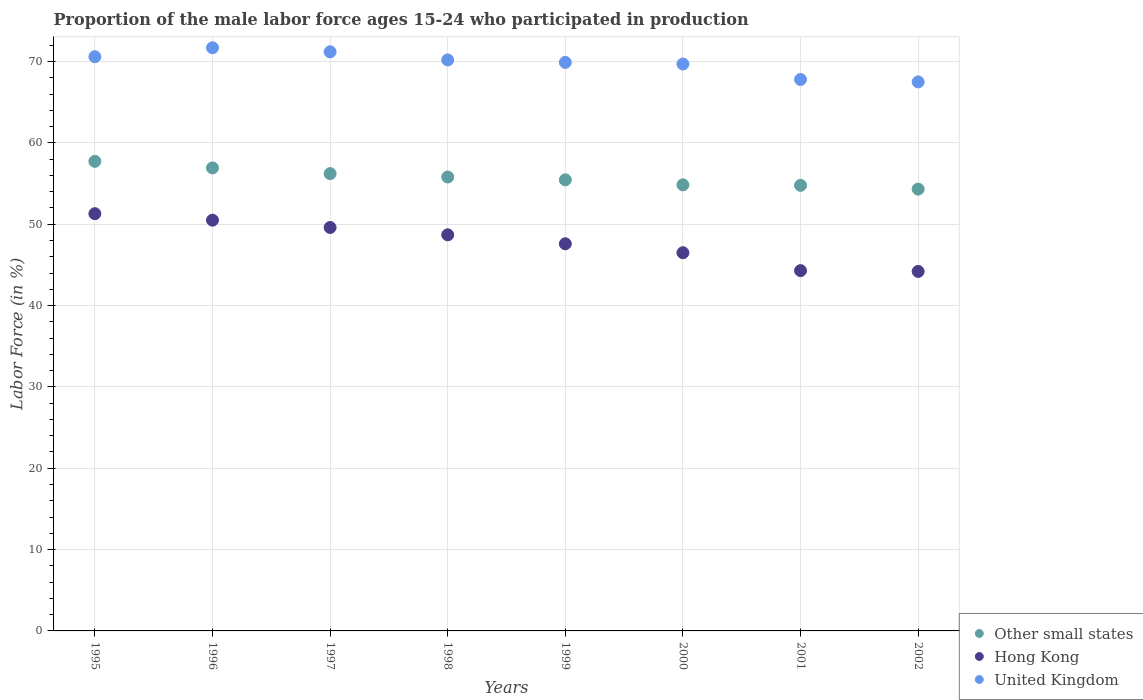Is the number of dotlines equal to the number of legend labels?
Your answer should be compact. Yes. What is the proportion of the male labor force who participated in production in Hong Kong in 1996?
Give a very brief answer. 50.5. Across all years, what is the maximum proportion of the male labor force who participated in production in Other small states?
Offer a terse response. 57.74. Across all years, what is the minimum proportion of the male labor force who participated in production in Hong Kong?
Ensure brevity in your answer.  44.2. In which year was the proportion of the male labor force who participated in production in United Kingdom maximum?
Ensure brevity in your answer.  1996. What is the total proportion of the male labor force who participated in production in Hong Kong in the graph?
Ensure brevity in your answer.  382.7. What is the difference between the proportion of the male labor force who participated in production in Hong Kong in 1997 and the proportion of the male labor force who participated in production in United Kingdom in 1995?
Your answer should be compact. -21. What is the average proportion of the male labor force who participated in production in Hong Kong per year?
Your answer should be very brief. 47.84. In the year 1995, what is the difference between the proportion of the male labor force who participated in production in Hong Kong and proportion of the male labor force who participated in production in United Kingdom?
Offer a very short reply. -19.3. What is the ratio of the proportion of the male labor force who participated in production in Hong Kong in 1997 to that in 1998?
Give a very brief answer. 1.02. Is the difference between the proportion of the male labor force who participated in production in Hong Kong in 1996 and 2000 greater than the difference between the proportion of the male labor force who participated in production in United Kingdom in 1996 and 2000?
Offer a very short reply. Yes. What is the difference between the highest and the second highest proportion of the male labor force who participated in production in Hong Kong?
Your response must be concise. 0.8. What is the difference between the highest and the lowest proportion of the male labor force who participated in production in United Kingdom?
Ensure brevity in your answer.  4.2. In how many years, is the proportion of the male labor force who participated in production in Hong Kong greater than the average proportion of the male labor force who participated in production in Hong Kong taken over all years?
Keep it short and to the point. 4. Is it the case that in every year, the sum of the proportion of the male labor force who participated in production in Other small states and proportion of the male labor force who participated in production in United Kingdom  is greater than the proportion of the male labor force who participated in production in Hong Kong?
Your response must be concise. Yes. Does the proportion of the male labor force who participated in production in United Kingdom monotonically increase over the years?
Your response must be concise. No. How many dotlines are there?
Offer a terse response. 3. How many years are there in the graph?
Your answer should be very brief. 8. What is the difference between two consecutive major ticks on the Y-axis?
Provide a succinct answer. 10. Are the values on the major ticks of Y-axis written in scientific E-notation?
Offer a terse response. No. Does the graph contain any zero values?
Provide a short and direct response. No. Does the graph contain grids?
Your answer should be compact. Yes. Where does the legend appear in the graph?
Give a very brief answer. Bottom right. How many legend labels are there?
Your response must be concise. 3. How are the legend labels stacked?
Your answer should be very brief. Vertical. What is the title of the graph?
Provide a short and direct response. Proportion of the male labor force ages 15-24 who participated in production. Does "Iraq" appear as one of the legend labels in the graph?
Your answer should be very brief. No. What is the Labor Force (in %) of Other small states in 1995?
Provide a succinct answer. 57.74. What is the Labor Force (in %) of Hong Kong in 1995?
Your answer should be compact. 51.3. What is the Labor Force (in %) in United Kingdom in 1995?
Provide a short and direct response. 70.6. What is the Labor Force (in %) in Other small states in 1996?
Your answer should be compact. 56.93. What is the Labor Force (in %) in Hong Kong in 1996?
Make the answer very short. 50.5. What is the Labor Force (in %) of United Kingdom in 1996?
Provide a succinct answer. 71.7. What is the Labor Force (in %) in Other small states in 1997?
Offer a terse response. 56.22. What is the Labor Force (in %) of Hong Kong in 1997?
Make the answer very short. 49.6. What is the Labor Force (in %) of United Kingdom in 1997?
Keep it short and to the point. 71.2. What is the Labor Force (in %) in Other small states in 1998?
Your response must be concise. 55.81. What is the Labor Force (in %) in Hong Kong in 1998?
Offer a terse response. 48.7. What is the Labor Force (in %) in United Kingdom in 1998?
Offer a terse response. 70.2. What is the Labor Force (in %) of Other small states in 1999?
Offer a terse response. 55.46. What is the Labor Force (in %) of Hong Kong in 1999?
Give a very brief answer. 47.6. What is the Labor Force (in %) in United Kingdom in 1999?
Your answer should be very brief. 69.9. What is the Labor Force (in %) of Other small states in 2000?
Make the answer very short. 54.84. What is the Labor Force (in %) of Hong Kong in 2000?
Ensure brevity in your answer.  46.5. What is the Labor Force (in %) in United Kingdom in 2000?
Offer a terse response. 69.7. What is the Labor Force (in %) of Other small states in 2001?
Your response must be concise. 54.78. What is the Labor Force (in %) in Hong Kong in 2001?
Offer a terse response. 44.3. What is the Labor Force (in %) of United Kingdom in 2001?
Provide a succinct answer. 67.8. What is the Labor Force (in %) in Other small states in 2002?
Your answer should be very brief. 54.32. What is the Labor Force (in %) of Hong Kong in 2002?
Make the answer very short. 44.2. What is the Labor Force (in %) of United Kingdom in 2002?
Ensure brevity in your answer.  67.5. Across all years, what is the maximum Labor Force (in %) in Other small states?
Offer a very short reply. 57.74. Across all years, what is the maximum Labor Force (in %) in Hong Kong?
Provide a short and direct response. 51.3. Across all years, what is the maximum Labor Force (in %) of United Kingdom?
Offer a very short reply. 71.7. Across all years, what is the minimum Labor Force (in %) of Other small states?
Offer a very short reply. 54.32. Across all years, what is the minimum Labor Force (in %) of Hong Kong?
Your response must be concise. 44.2. Across all years, what is the minimum Labor Force (in %) of United Kingdom?
Keep it short and to the point. 67.5. What is the total Labor Force (in %) in Other small states in the graph?
Make the answer very short. 446.1. What is the total Labor Force (in %) in Hong Kong in the graph?
Offer a very short reply. 382.7. What is the total Labor Force (in %) in United Kingdom in the graph?
Your answer should be compact. 558.6. What is the difference between the Labor Force (in %) in Other small states in 1995 and that in 1996?
Your answer should be compact. 0.81. What is the difference between the Labor Force (in %) in United Kingdom in 1995 and that in 1996?
Ensure brevity in your answer.  -1.1. What is the difference between the Labor Force (in %) in Other small states in 1995 and that in 1997?
Ensure brevity in your answer.  1.51. What is the difference between the Labor Force (in %) of Hong Kong in 1995 and that in 1997?
Your answer should be compact. 1.7. What is the difference between the Labor Force (in %) of Other small states in 1995 and that in 1998?
Your response must be concise. 1.93. What is the difference between the Labor Force (in %) in Hong Kong in 1995 and that in 1998?
Your answer should be very brief. 2.6. What is the difference between the Labor Force (in %) of United Kingdom in 1995 and that in 1998?
Keep it short and to the point. 0.4. What is the difference between the Labor Force (in %) of Other small states in 1995 and that in 1999?
Provide a short and direct response. 2.27. What is the difference between the Labor Force (in %) of United Kingdom in 1995 and that in 1999?
Offer a very short reply. 0.7. What is the difference between the Labor Force (in %) in Other small states in 1995 and that in 2000?
Your answer should be very brief. 2.89. What is the difference between the Labor Force (in %) of Hong Kong in 1995 and that in 2000?
Your response must be concise. 4.8. What is the difference between the Labor Force (in %) in United Kingdom in 1995 and that in 2000?
Provide a succinct answer. 0.9. What is the difference between the Labor Force (in %) of Other small states in 1995 and that in 2001?
Your response must be concise. 2.95. What is the difference between the Labor Force (in %) of Other small states in 1995 and that in 2002?
Provide a short and direct response. 3.42. What is the difference between the Labor Force (in %) of Hong Kong in 1995 and that in 2002?
Make the answer very short. 7.1. What is the difference between the Labor Force (in %) in United Kingdom in 1995 and that in 2002?
Provide a short and direct response. 3.1. What is the difference between the Labor Force (in %) of Other small states in 1996 and that in 1997?
Provide a short and direct response. 0.7. What is the difference between the Labor Force (in %) of Other small states in 1996 and that in 1998?
Give a very brief answer. 1.12. What is the difference between the Labor Force (in %) of Hong Kong in 1996 and that in 1998?
Keep it short and to the point. 1.8. What is the difference between the Labor Force (in %) in Other small states in 1996 and that in 1999?
Your answer should be compact. 1.46. What is the difference between the Labor Force (in %) in Hong Kong in 1996 and that in 1999?
Offer a very short reply. 2.9. What is the difference between the Labor Force (in %) in United Kingdom in 1996 and that in 1999?
Offer a terse response. 1.8. What is the difference between the Labor Force (in %) of Other small states in 1996 and that in 2000?
Make the answer very short. 2.08. What is the difference between the Labor Force (in %) in Hong Kong in 1996 and that in 2000?
Offer a very short reply. 4. What is the difference between the Labor Force (in %) in United Kingdom in 1996 and that in 2000?
Your answer should be compact. 2. What is the difference between the Labor Force (in %) of Other small states in 1996 and that in 2001?
Give a very brief answer. 2.15. What is the difference between the Labor Force (in %) in Other small states in 1996 and that in 2002?
Provide a succinct answer. 2.61. What is the difference between the Labor Force (in %) of Other small states in 1997 and that in 1998?
Make the answer very short. 0.41. What is the difference between the Labor Force (in %) in Hong Kong in 1997 and that in 1998?
Your response must be concise. 0.9. What is the difference between the Labor Force (in %) of United Kingdom in 1997 and that in 1998?
Your response must be concise. 1. What is the difference between the Labor Force (in %) in Other small states in 1997 and that in 1999?
Your answer should be very brief. 0.76. What is the difference between the Labor Force (in %) of United Kingdom in 1997 and that in 1999?
Ensure brevity in your answer.  1.3. What is the difference between the Labor Force (in %) of Other small states in 1997 and that in 2000?
Your response must be concise. 1.38. What is the difference between the Labor Force (in %) of Hong Kong in 1997 and that in 2000?
Your response must be concise. 3.1. What is the difference between the Labor Force (in %) of United Kingdom in 1997 and that in 2000?
Your response must be concise. 1.5. What is the difference between the Labor Force (in %) in Other small states in 1997 and that in 2001?
Make the answer very short. 1.44. What is the difference between the Labor Force (in %) in United Kingdom in 1997 and that in 2001?
Provide a short and direct response. 3.4. What is the difference between the Labor Force (in %) in Other small states in 1997 and that in 2002?
Provide a succinct answer. 1.9. What is the difference between the Labor Force (in %) in Hong Kong in 1997 and that in 2002?
Your answer should be very brief. 5.4. What is the difference between the Labor Force (in %) of Other small states in 1998 and that in 1999?
Ensure brevity in your answer.  0.35. What is the difference between the Labor Force (in %) of Hong Kong in 1998 and that in 1999?
Your answer should be very brief. 1.1. What is the difference between the Labor Force (in %) of United Kingdom in 1998 and that in 1999?
Provide a short and direct response. 0.3. What is the difference between the Labor Force (in %) of Other small states in 1998 and that in 2000?
Provide a succinct answer. 0.97. What is the difference between the Labor Force (in %) in United Kingdom in 1998 and that in 2000?
Offer a terse response. 0.5. What is the difference between the Labor Force (in %) of Other small states in 1998 and that in 2001?
Offer a terse response. 1.03. What is the difference between the Labor Force (in %) in United Kingdom in 1998 and that in 2001?
Provide a succinct answer. 2.4. What is the difference between the Labor Force (in %) in Other small states in 1998 and that in 2002?
Your answer should be very brief. 1.49. What is the difference between the Labor Force (in %) of Other small states in 1999 and that in 2000?
Offer a terse response. 0.62. What is the difference between the Labor Force (in %) in United Kingdom in 1999 and that in 2000?
Ensure brevity in your answer.  0.2. What is the difference between the Labor Force (in %) in Other small states in 1999 and that in 2001?
Provide a short and direct response. 0.68. What is the difference between the Labor Force (in %) of United Kingdom in 1999 and that in 2001?
Provide a succinct answer. 2.1. What is the difference between the Labor Force (in %) in Hong Kong in 1999 and that in 2002?
Your answer should be compact. 3.4. What is the difference between the Labor Force (in %) in United Kingdom in 1999 and that in 2002?
Make the answer very short. 2.4. What is the difference between the Labor Force (in %) in Other small states in 2000 and that in 2001?
Make the answer very short. 0.06. What is the difference between the Labor Force (in %) of Hong Kong in 2000 and that in 2001?
Your answer should be compact. 2.2. What is the difference between the Labor Force (in %) in Other small states in 2000 and that in 2002?
Your answer should be very brief. 0.52. What is the difference between the Labor Force (in %) in Other small states in 2001 and that in 2002?
Offer a terse response. 0.46. What is the difference between the Labor Force (in %) of United Kingdom in 2001 and that in 2002?
Your answer should be very brief. 0.3. What is the difference between the Labor Force (in %) of Other small states in 1995 and the Labor Force (in %) of Hong Kong in 1996?
Make the answer very short. 7.24. What is the difference between the Labor Force (in %) in Other small states in 1995 and the Labor Force (in %) in United Kingdom in 1996?
Your answer should be compact. -13.96. What is the difference between the Labor Force (in %) in Hong Kong in 1995 and the Labor Force (in %) in United Kingdom in 1996?
Give a very brief answer. -20.4. What is the difference between the Labor Force (in %) of Other small states in 1995 and the Labor Force (in %) of Hong Kong in 1997?
Keep it short and to the point. 8.14. What is the difference between the Labor Force (in %) of Other small states in 1995 and the Labor Force (in %) of United Kingdom in 1997?
Offer a terse response. -13.46. What is the difference between the Labor Force (in %) in Hong Kong in 1995 and the Labor Force (in %) in United Kingdom in 1997?
Give a very brief answer. -19.9. What is the difference between the Labor Force (in %) of Other small states in 1995 and the Labor Force (in %) of Hong Kong in 1998?
Keep it short and to the point. 9.04. What is the difference between the Labor Force (in %) in Other small states in 1995 and the Labor Force (in %) in United Kingdom in 1998?
Your answer should be compact. -12.46. What is the difference between the Labor Force (in %) of Hong Kong in 1995 and the Labor Force (in %) of United Kingdom in 1998?
Ensure brevity in your answer.  -18.9. What is the difference between the Labor Force (in %) in Other small states in 1995 and the Labor Force (in %) in Hong Kong in 1999?
Your answer should be compact. 10.14. What is the difference between the Labor Force (in %) of Other small states in 1995 and the Labor Force (in %) of United Kingdom in 1999?
Make the answer very short. -12.16. What is the difference between the Labor Force (in %) of Hong Kong in 1995 and the Labor Force (in %) of United Kingdom in 1999?
Your answer should be very brief. -18.6. What is the difference between the Labor Force (in %) in Other small states in 1995 and the Labor Force (in %) in Hong Kong in 2000?
Provide a succinct answer. 11.24. What is the difference between the Labor Force (in %) of Other small states in 1995 and the Labor Force (in %) of United Kingdom in 2000?
Provide a short and direct response. -11.96. What is the difference between the Labor Force (in %) of Hong Kong in 1995 and the Labor Force (in %) of United Kingdom in 2000?
Give a very brief answer. -18.4. What is the difference between the Labor Force (in %) in Other small states in 1995 and the Labor Force (in %) in Hong Kong in 2001?
Keep it short and to the point. 13.44. What is the difference between the Labor Force (in %) of Other small states in 1995 and the Labor Force (in %) of United Kingdom in 2001?
Make the answer very short. -10.06. What is the difference between the Labor Force (in %) in Hong Kong in 1995 and the Labor Force (in %) in United Kingdom in 2001?
Make the answer very short. -16.5. What is the difference between the Labor Force (in %) in Other small states in 1995 and the Labor Force (in %) in Hong Kong in 2002?
Give a very brief answer. 13.54. What is the difference between the Labor Force (in %) in Other small states in 1995 and the Labor Force (in %) in United Kingdom in 2002?
Your answer should be compact. -9.76. What is the difference between the Labor Force (in %) in Hong Kong in 1995 and the Labor Force (in %) in United Kingdom in 2002?
Your response must be concise. -16.2. What is the difference between the Labor Force (in %) of Other small states in 1996 and the Labor Force (in %) of Hong Kong in 1997?
Your answer should be very brief. 7.33. What is the difference between the Labor Force (in %) of Other small states in 1996 and the Labor Force (in %) of United Kingdom in 1997?
Provide a succinct answer. -14.27. What is the difference between the Labor Force (in %) in Hong Kong in 1996 and the Labor Force (in %) in United Kingdom in 1997?
Ensure brevity in your answer.  -20.7. What is the difference between the Labor Force (in %) in Other small states in 1996 and the Labor Force (in %) in Hong Kong in 1998?
Give a very brief answer. 8.23. What is the difference between the Labor Force (in %) of Other small states in 1996 and the Labor Force (in %) of United Kingdom in 1998?
Give a very brief answer. -13.27. What is the difference between the Labor Force (in %) of Hong Kong in 1996 and the Labor Force (in %) of United Kingdom in 1998?
Your answer should be very brief. -19.7. What is the difference between the Labor Force (in %) of Other small states in 1996 and the Labor Force (in %) of Hong Kong in 1999?
Provide a succinct answer. 9.33. What is the difference between the Labor Force (in %) of Other small states in 1996 and the Labor Force (in %) of United Kingdom in 1999?
Ensure brevity in your answer.  -12.97. What is the difference between the Labor Force (in %) of Hong Kong in 1996 and the Labor Force (in %) of United Kingdom in 1999?
Your answer should be compact. -19.4. What is the difference between the Labor Force (in %) of Other small states in 1996 and the Labor Force (in %) of Hong Kong in 2000?
Offer a terse response. 10.43. What is the difference between the Labor Force (in %) in Other small states in 1996 and the Labor Force (in %) in United Kingdom in 2000?
Provide a short and direct response. -12.77. What is the difference between the Labor Force (in %) in Hong Kong in 1996 and the Labor Force (in %) in United Kingdom in 2000?
Keep it short and to the point. -19.2. What is the difference between the Labor Force (in %) of Other small states in 1996 and the Labor Force (in %) of Hong Kong in 2001?
Make the answer very short. 12.63. What is the difference between the Labor Force (in %) of Other small states in 1996 and the Labor Force (in %) of United Kingdom in 2001?
Keep it short and to the point. -10.87. What is the difference between the Labor Force (in %) in Hong Kong in 1996 and the Labor Force (in %) in United Kingdom in 2001?
Ensure brevity in your answer.  -17.3. What is the difference between the Labor Force (in %) in Other small states in 1996 and the Labor Force (in %) in Hong Kong in 2002?
Keep it short and to the point. 12.73. What is the difference between the Labor Force (in %) of Other small states in 1996 and the Labor Force (in %) of United Kingdom in 2002?
Provide a succinct answer. -10.57. What is the difference between the Labor Force (in %) of Other small states in 1997 and the Labor Force (in %) of Hong Kong in 1998?
Your answer should be compact. 7.52. What is the difference between the Labor Force (in %) of Other small states in 1997 and the Labor Force (in %) of United Kingdom in 1998?
Make the answer very short. -13.98. What is the difference between the Labor Force (in %) in Hong Kong in 1997 and the Labor Force (in %) in United Kingdom in 1998?
Offer a terse response. -20.6. What is the difference between the Labor Force (in %) of Other small states in 1997 and the Labor Force (in %) of Hong Kong in 1999?
Offer a terse response. 8.62. What is the difference between the Labor Force (in %) of Other small states in 1997 and the Labor Force (in %) of United Kingdom in 1999?
Your answer should be compact. -13.68. What is the difference between the Labor Force (in %) in Hong Kong in 1997 and the Labor Force (in %) in United Kingdom in 1999?
Your answer should be very brief. -20.3. What is the difference between the Labor Force (in %) in Other small states in 1997 and the Labor Force (in %) in Hong Kong in 2000?
Your answer should be compact. 9.72. What is the difference between the Labor Force (in %) in Other small states in 1997 and the Labor Force (in %) in United Kingdom in 2000?
Your answer should be very brief. -13.48. What is the difference between the Labor Force (in %) of Hong Kong in 1997 and the Labor Force (in %) of United Kingdom in 2000?
Your answer should be very brief. -20.1. What is the difference between the Labor Force (in %) of Other small states in 1997 and the Labor Force (in %) of Hong Kong in 2001?
Make the answer very short. 11.92. What is the difference between the Labor Force (in %) in Other small states in 1997 and the Labor Force (in %) in United Kingdom in 2001?
Your response must be concise. -11.58. What is the difference between the Labor Force (in %) in Hong Kong in 1997 and the Labor Force (in %) in United Kingdom in 2001?
Offer a terse response. -18.2. What is the difference between the Labor Force (in %) in Other small states in 1997 and the Labor Force (in %) in Hong Kong in 2002?
Keep it short and to the point. 12.02. What is the difference between the Labor Force (in %) of Other small states in 1997 and the Labor Force (in %) of United Kingdom in 2002?
Offer a very short reply. -11.28. What is the difference between the Labor Force (in %) in Hong Kong in 1997 and the Labor Force (in %) in United Kingdom in 2002?
Give a very brief answer. -17.9. What is the difference between the Labor Force (in %) of Other small states in 1998 and the Labor Force (in %) of Hong Kong in 1999?
Give a very brief answer. 8.21. What is the difference between the Labor Force (in %) in Other small states in 1998 and the Labor Force (in %) in United Kingdom in 1999?
Provide a short and direct response. -14.09. What is the difference between the Labor Force (in %) in Hong Kong in 1998 and the Labor Force (in %) in United Kingdom in 1999?
Provide a short and direct response. -21.2. What is the difference between the Labor Force (in %) of Other small states in 1998 and the Labor Force (in %) of Hong Kong in 2000?
Your answer should be compact. 9.31. What is the difference between the Labor Force (in %) in Other small states in 1998 and the Labor Force (in %) in United Kingdom in 2000?
Ensure brevity in your answer.  -13.89. What is the difference between the Labor Force (in %) in Hong Kong in 1998 and the Labor Force (in %) in United Kingdom in 2000?
Provide a succinct answer. -21. What is the difference between the Labor Force (in %) in Other small states in 1998 and the Labor Force (in %) in Hong Kong in 2001?
Ensure brevity in your answer.  11.51. What is the difference between the Labor Force (in %) of Other small states in 1998 and the Labor Force (in %) of United Kingdom in 2001?
Keep it short and to the point. -11.99. What is the difference between the Labor Force (in %) in Hong Kong in 1998 and the Labor Force (in %) in United Kingdom in 2001?
Keep it short and to the point. -19.1. What is the difference between the Labor Force (in %) of Other small states in 1998 and the Labor Force (in %) of Hong Kong in 2002?
Your answer should be very brief. 11.61. What is the difference between the Labor Force (in %) in Other small states in 1998 and the Labor Force (in %) in United Kingdom in 2002?
Offer a terse response. -11.69. What is the difference between the Labor Force (in %) in Hong Kong in 1998 and the Labor Force (in %) in United Kingdom in 2002?
Offer a terse response. -18.8. What is the difference between the Labor Force (in %) of Other small states in 1999 and the Labor Force (in %) of Hong Kong in 2000?
Offer a terse response. 8.96. What is the difference between the Labor Force (in %) in Other small states in 1999 and the Labor Force (in %) in United Kingdom in 2000?
Give a very brief answer. -14.24. What is the difference between the Labor Force (in %) of Hong Kong in 1999 and the Labor Force (in %) of United Kingdom in 2000?
Give a very brief answer. -22.1. What is the difference between the Labor Force (in %) of Other small states in 1999 and the Labor Force (in %) of Hong Kong in 2001?
Keep it short and to the point. 11.16. What is the difference between the Labor Force (in %) in Other small states in 1999 and the Labor Force (in %) in United Kingdom in 2001?
Make the answer very short. -12.34. What is the difference between the Labor Force (in %) of Hong Kong in 1999 and the Labor Force (in %) of United Kingdom in 2001?
Give a very brief answer. -20.2. What is the difference between the Labor Force (in %) in Other small states in 1999 and the Labor Force (in %) in Hong Kong in 2002?
Your answer should be very brief. 11.26. What is the difference between the Labor Force (in %) in Other small states in 1999 and the Labor Force (in %) in United Kingdom in 2002?
Your answer should be very brief. -12.04. What is the difference between the Labor Force (in %) of Hong Kong in 1999 and the Labor Force (in %) of United Kingdom in 2002?
Provide a succinct answer. -19.9. What is the difference between the Labor Force (in %) of Other small states in 2000 and the Labor Force (in %) of Hong Kong in 2001?
Your answer should be very brief. 10.54. What is the difference between the Labor Force (in %) in Other small states in 2000 and the Labor Force (in %) in United Kingdom in 2001?
Your response must be concise. -12.96. What is the difference between the Labor Force (in %) of Hong Kong in 2000 and the Labor Force (in %) of United Kingdom in 2001?
Offer a very short reply. -21.3. What is the difference between the Labor Force (in %) in Other small states in 2000 and the Labor Force (in %) in Hong Kong in 2002?
Make the answer very short. 10.64. What is the difference between the Labor Force (in %) in Other small states in 2000 and the Labor Force (in %) in United Kingdom in 2002?
Provide a succinct answer. -12.66. What is the difference between the Labor Force (in %) of Hong Kong in 2000 and the Labor Force (in %) of United Kingdom in 2002?
Provide a succinct answer. -21. What is the difference between the Labor Force (in %) of Other small states in 2001 and the Labor Force (in %) of Hong Kong in 2002?
Keep it short and to the point. 10.58. What is the difference between the Labor Force (in %) in Other small states in 2001 and the Labor Force (in %) in United Kingdom in 2002?
Offer a terse response. -12.72. What is the difference between the Labor Force (in %) of Hong Kong in 2001 and the Labor Force (in %) of United Kingdom in 2002?
Give a very brief answer. -23.2. What is the average Labor Force (in %) in Other small states per year?
Keep it short and to the point. 55.76. What is the average Labor Force (in %) of Hong Kong per year?
Offer a very short reply. 47.84. What is the average Labor Force (in %) in United Kingdom per year?
Make the answer very short. 69.83. In the year 1995, what is the difference between the Labor Force (in %) of Other small states and Labor Force (in %) of Hong Kong?
Offer a terse response. 6.44. In the year 1995, what is the difference between the Labor Force (in %) in Other small states and Labor Force (in %) in United Kingdom?
Offer a very short reply. -12.86. In the year 1995, what is the difference between the Labor Force (in %) of Hong Kong and Labor Force (in %) of United Kingdom?
Your answer should be compact. -19.3. In the year 1996, what is the difference between the Labor Force (in %) in Other small states and Labor Force (in %) in Hong Kong?
Your response must be concise. 6.43. In the year 1996, what is the difference between the Labor Force (in %) in Other small states and Labor Force (in %) in United Kingdom?
Ensure brevity in your answer.  -14.77. In the year 1996, what is the difference between the Labor Force (in %) of Hong Kong and Labor Force (in %) of United Kingdom?
Ensure brevity in your answer.  -21.2. In the year 1997, what is the difference between the Labor Force (in %) of Other small states and Labor Force (in %) of Hong Kong?
Ensure brevity in your answer.  6.62. In the year 1997, what is the difference between the Labor Force (in %) in Other small states and Labor Force (in %) in United Kingdom?
Provide a succinct answer. -14.98. In the year 1997, what is the difference between the Labor Force (in %) of Hong Kong and Labor Force (in %) of United Kingdom?
Offer a terse response. -21.6. In the year 1998, what is the difference between the Labor Force (in %) of Other small states and Labor Force (in %) of Hong Kong?
Provide a succinct answer. 7.11. In the year 1998, what is the difference between the Labor Force (in %) in Other small states and Labor Force (in %) in United Kingdom?
Offer a terse response. -14.39. In the year 1998, what is the difference between the Labor Force (in %) in Hong Kong and Labor Force (in %) in United Kingdom?
Offer a very short reply. -21.5. In the year 1999, what is the difference between the Labor Force (in %) of Other small states and Labor Force (in %) of Hong Kong?
Provide a short and direct response. 7.86. In the year 1999, what is the difference between the Labor Force (in %) of Other small states and Labor Force (in %) of United Kingdom?
Your answer should be compact. -14.44. In the year 1999, what is the difference between the Labor Force (in %) of Hong Kong and Labor Force (in %) of United Kingdom?
Your answer should be compact. -22.3. In the year 2000, what is the difference between the Labor Force (in %) in Other small states and Labor Force (in %) in Hong Kong?
Make the answer very short. 8.34. In the year 2000, what is the difference between the Labor Force (in %) in Other small states and Labor Force (in %) in United Kingdom?
Keep it short and to the point. -14.86. In the year 2000, what is the difference between the Labor Force (in %) in Hong Kong and Labor Force (in %) in United Kingdom?
Your response must be concise. -23.2. In the year 2001, what is the difference between the Labor Force (in %) of Other small states and Labor Force (in %) of Hong Kong?
Make the answer very short. 10.48. In the year 2001, what is the difference between the Labor Force (in %) of Other small states and Labor Force (in %) of United Kingdom?
Your response must be concise. -13.02. In the year 2001, what is the difference between the Labor Force (in %) of Hong Kong and Labor Force (in %) of United Kingdom?
Give a very brief answer. -23.5. In the year 2002, what is the difference between the Labor Force (in %) of Other small states and Labor Force (in %) of Hong Kong?
Give a very brief answer. 10.12. In the year 2002, what is the difference between the Labor Force (in %) in Other small states and Labor Force (in %) in United Kingdom?
Your answer should be compact. -13.18. In the year 2002, what is the difference between the Labor Force (in %) of Hong Kong and Labor Force (in %) of United Kingdom?
Make the answer very short. -23.3. What is the ratio of the Labor Force (in %) of Other small states in 1995 to that in 1996?
Your answer should be very brief. 1.01. What is the ratio of the Labor Force (in %) of Hong Kong in 1995 to that in 1996?
Give a very brief answer. 1.02. What is the ratio of the Labor Force (in %) in United Kingdom in 1995 to that in 1996?
Your response must be concise. 0.98. What is the ratio of the Labor Force (in %) of Other small states in 1995 to that in 1997?
Offer a very short reply. 1.03. What is the ratio of the Labor Force (in %) in Hong Kong in 1995 to that in 1997?
Make the answer very short. 1.03. What is the ratio of the Labor Force (in %) of United Kingdom in 1995 to that in 1997?
Your answer should be compact. 0.99. What is the ratio of the Labor Force (in %) in Other small states in 1995 to that in 1998?
Provide a short and direct response. 1.03. What is the ratio of the Labor Force (in %) in Hong Kong in 1995 to that in 1998?
Make the answer very short. 1.05. What is the ratio of the Labor Force (in %) of United Kingdom in 1995 to that in 1998?
Your answer should be compact. 1.01. What is the ratio of the Labor Force (in %) of Other small states in 1995 to that in 1999?
Provide a succinct answer. 1.04. What is the ratio of the Labor Force (in %) in Hong Kong in 1995 to that in 1999?
Your answer should be compact. 1.08. What is the ratio of the Labor Force (in %) in Other small states in 1995 to that in 2000?
Keep it short and to the point. 1.05. What is the ratio of the Labor Force (in %) in Hong Kong in 1995 to that in 2000?
Provide a short and direct response. 1.1. What is the ratio of the Labor Force (in %) of United Kingdom in 1995 to that in 2000?
Keep it short and to the point. 1.01. What is the ratio of the Labor Force (in %) of Other small states in 1995 to that in 2001?
Keep it short and to the point. 1.05. What is the ratio of the Labor Force (in %) in Hong Kong in 1995 to that in 2001?
Keep it short and to the point. 1.16. What is the ratio of the Labor Force (in %) of United Kingdom in 1995 to that in 2001?
Make the answer very short. 1.04. What is the ratio of the Labor Force (in %) in Other small states in 1995 to that in 2002?
Provide a succinct answer. 1.06. What is the ratio of the Labor Force (in %) of Hong Kong in 1995 to that in 2002?
Provide a succinct answer. 1.16. What is the ratio of the Labor Force (in %) of United Kingdom in 1995 to that in 2002?
Provide a succinct answer. 1.05. What is the ratio of the Labor Force (in %) in Other small states in 1996 to that in 1997?
Provide a short and direct response. 1.01. What is the ratio of the Labor Force (in %) of Hong Kong in 1996 to that in 1997?
Your response must be concise. 1.02. What is the ratio of the Labor Force (in %) of United Kingdom in 1996 to that in 1997?
Your answer should be very brief. 1.01. What is the ratio of the Labor Force (in %) of Other small states in 1996 to that in 1998?
Your answer should be compact. 1.02. What is the ratio of the Labor Force (in %) in Hong Kong in 1996 to that in 1998?
Your answer should be very brief. 1.04. What is the ratio of the Labor Force (in %) of United Kingdom in 1996 to that in 1998?
Your answer should be compact. 1.02. What is the ratio of the Labor Force (in %) in Other small states in 1996 to that in 1999?
Ensure brevity in your answer.  1.03. What is the ratio of the Labor Force (in %) of Hong Kong in 1996 to that in 1999?
Provide a short and direct response. 1.06. What is the ratio of the Labor Force (in %) in United Kingdom in 1996 to that in 1999?
Provide a short and direct response. 1.03. What is the ratio of the Labor Force (in %) in Other small states in 1996 to that in 2000?
Give a very brief answer. 1.04. What is the ratio of the Labor Force (in %) of Hong Kong in 1996 to that in 2000?
Make the answer very short. 1.09. What is the ratio of the Labor Force (in %) of United Kingdom in 1996 to that in 2000?
Ensure brevity in your answer.  1.03. What is the ratio of the Labor Force (in %) of Other small states in 1996 to that in 2001?
Keep it short and to the point. 1.04. What is the ratio of the Labor Force (in %) of Hong Kong in 1996 to that in 2001?
Offer a terse response. 1.14. What is the ratio of the Labor Force (in %) in United Kingdom in 1996 to that in 2001?
Your answer should be compact. 1.06. What is the ratio of the Labor Force (in %) of Other small states in 1996 to that in 2002?
Provide a short and direct response. 1.05. What is the ratio of the Labor Force (in %) in Hong Kong in 1996 to that in 2002?
Offer a very short reply. 1.14. What is the ratio of the Labor Force (in %) of United Kingdom in 1996 to that in 2002?
Provide a succinct answer. 1.06. What is the ratio of the Labor Force (in %) in Other small states in 1997 to that in 1998?
Provide a short and direct response. 1.01. What is the ratio of the Labor Force (in %) of Hong Kong in 1997 to that in 1998?
Your answer should be compact. 1.02. What is the ratio of the Labor Force (in %) of United Kingdom in 1997 to that in 1998?
Give a very brief answer. 1.01. What is the ratio of the Labor Force (in %) of Other small states in 1997 to that in 1999?
Your answer should be very brief. 1.01. What is the ratio of the Labor Force (in %) of Hong Kong in 1997 to that in 1999?
Offer a terse response. 1.04. What is the ratio of the Labor Force (in %) in United Kingdom in 1997 to that in 1999?
Your answer should be very brief. 1.02. What is the ratio of the Labor Force (in %) of Other small states in 1997 to that in 2000?
Provide a succinct answer. 1.03. What is the ratio of the Labor Force (in %) of Hong Kong in 1997 to that in 2000?
Keep it short and to the point. 1.07. What is the ratio of the Labor Force (in %) of United Kingdom in 1997 to that in 2000?
Give a very brief answer. 1.02. What is the ratio of the Labor Force (in %) in Other small states in 1997 to that in 2001?
Provide a short and direct response. 1.03. What is the ratio of the Labor Force (in %) in Hong Kong in 1997 to that in 2001?
Your answer should be very brief. 1.12. What is the ratio of the Labor Force (in %) in United Kingdom in 1997 to that in 2001?
Give a very brief answer. 1.05. What is the ratio of the Labor Force (in %) in Other small states in 1997 to that in 2002?
Your answer should be very brief. 1.04. What is the ratio of the Labor Force (in %) in Hong Kong in 1997 to that in 2002?
Offer a very short reply. 1.12. What is the ratio of the Labor Force (in %) in United Kingdom in 1997 to that in 2002?
Your response must be concise. 1.05. What is the ratio of the Labor Force (in %) of Hong Kong in 1998 to that in 1999?
Offer a terse response. 1.02. What is the ratio of the Labor Force (in %) of United Kingdom in 1998 to that in 1999?
Provide a short and direct response. 1. What is the ratio of the Labor Force (in %) in Other small states in 1998 to that in 2000?
Offer a terse response. 1.02. What is the ratio of the Labor Force (in %) in Hong Kong in 1998 to that in 2000?
Your answer should be compact. 1.05. What is the ratio of the Labor Force (in %) of United Kingdom in 1998 to that in 2000?
Your answer should be very brief. 1.01. What is the ratio of the Labor Force (in %) of Other small states in 1998 to that in 2001?
Keep it short and to the point. 1.02. What is the ratio of the Labor Force (in %) in Hong Kong in 1998 to that in 2001?
Provide a succinct answer. 1.1. What is the ratio of the Labor Force (in %) of United Kingdom in 1998 to that in 2001?
Your answer should be compact. 1.04. What is the ratio of the Labor Force (in %) of Other small states in 1998 to that in 2002?
Ensure brevity in your answer.  1.03. What is the ratio of the Labor Force (in %) in Hong Kong in 1998 to that in 2002?
Ensure brevity in your answer.  1.1. What is the ratio of the Labor Force (in %) of Other small states in 1999 to that in 2000?
Offer a very short reply. 1.01. What is the ratio of the Labor Force (in %) in Hong Kong in 1999 to that in 2000?
Ensure brevity in your answer.  1.02. What is the ratio of the Labor Force (in %) of United Kingdom in 1999 to that in 2000?
Offer a terse response. 1. What is the ratio of the Labor Force (in %) of Other small states in 1999 to that in 2001?
Your answer should be very brief. 1.01. What is the ratio of the Labor Force (in %) of Hong Kong in 1999 to that in 2001?
Your answer should be very brief. 1.07. What is the ratio of the Labor Force (in %) in United Kingdom in 1999 to that in 2001?
Provide a short and direct response. 1.03. What is the ratio of the Labor Force (in %) in Other small states in 1999 to that in 2002?
Make the answer very short. 1.02. What is the ratio of the Labor Force (in %) of Hong Kong in 1999 to that in 2002?
Keep it short and to the point. 1.08. What is the ratio of the Labor Force (in %) of United Kingdom in 1999 to that in 2002?
Give a very brief answer. 1.04. What is the ratio of the Labor Force (in %) of Hong Kong in 2000 to that in 2001?
Ensure brevity in your answer.  1.05. What is the ratio of the Labor Force (in %) of United Kingdom in 2000 to that in 2001?
Provide a short and direct response. 1.03. What is the ratio of the Labor Force (in %) in Other small states in 2000 to that in 2002?
Give a very brief answer. 1.01. What is the ratio of the Labor Force (in %) of Hong Kong in 2000 to that in 2002?
Give a very brief answer. 1.05. What is the ratio of the Labor Force (in %) of United Kingdom in 2000 to that in 2002?
Offer a terse response. 1.03. What is the ratio of the Labor Force (in %) of Other small states in 2001 to that in 2002?
Provide a short and direct response. 1.01. What is the ratio of the Labor Force (in %) of United Kingdom in 2001 to that in 2002?
Your response must be concise. 1. What is the difference between the highest and the second highest Labor Force (in %) of Other small states?
Your response must be concise. 0.81. What is the difference between the highest and the second highest Labor Force (in %) of Hong Kong?
Make the answer very short. 0.8. What is the difference between the highest and the lowest Labor Force (in %) of Other small states?
Give a very brief answer. 3.42. What is the difference between the highest and the lowest Labor Force (in %) of Hong Kong?
Provide a succinct answer. 7.1. What is the difference between the highest and the lowest Labor Force (in %) of United Kingdom?
Keep it short and to the point. 4.2. 